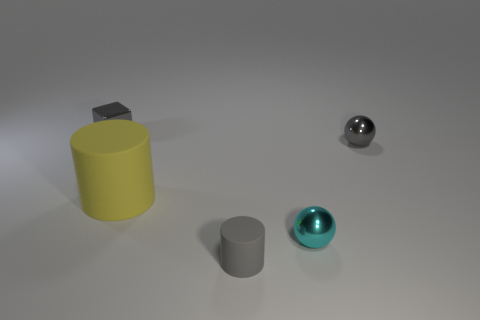Add 5 big matte things. How many objects exist? 10 Subtract all cubes. How many objects are left? 4 Subtract 0 red cubes. How many objects are left? 5 Subtract all small purple rubber things. Subtract all gray metal things. How many objects are left? 3 Add 5 small cyan spheres. How many small cyan spheres are left? 6 Add 1 red things. How many red things exist? 1 